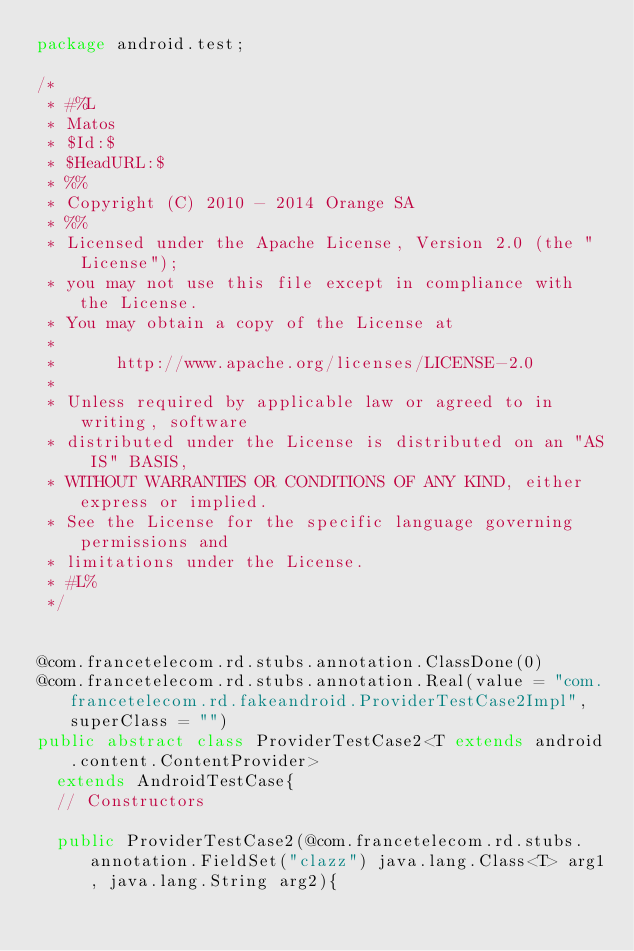Convert code to text. <code><loc_0><loc_0><loc_500><loc_500><_Java_>package android.test;

/*
 * #%L
 * Matos
 * $Id:$
 * $HeadURL:$
 * %%
 * Copyright (C) 2010 - 2014 Orange SA
 * %%
 * Licensed under the Apache License, Version 2.0 (the "License");
 * you may not use this file except in compliance with the License.
 * You may obtain a copy of the License at
 * 
 *      http://www.apache.org/licenses/LICENSE-2.0
 * 
 * Unless required by applicable law or agreed to in writing, software
 * distributed under the License is distributed on an "AS IS" BASIS,
 * WITHOUT WARRANTIES OR CONDITIONS OF ANY KIND, either express or implied.
 * See the License for the specific language governing permissions and
 * limitations under the License.
 * #L%
 */


@com.francetelecom.rd.stubs.annotation.ClassDone(0)
@com.francetelecom.rd.stubs.annotation.Real(value = "com.francetelecom.rd.fakeandroid.ProviderTestCase2Impl", superClass = "")
public abstract class ProviderTestCase2<T extends android.content.ContentProvider>
  extends AndroidTestCase{
  // Constructors

  public ProviderTestCase2(@com.francetelecom.rd.stubs.annotation.FieldSet("clazz") java.lang.Class<T> arg1, java.lang.String arg2){</code> 